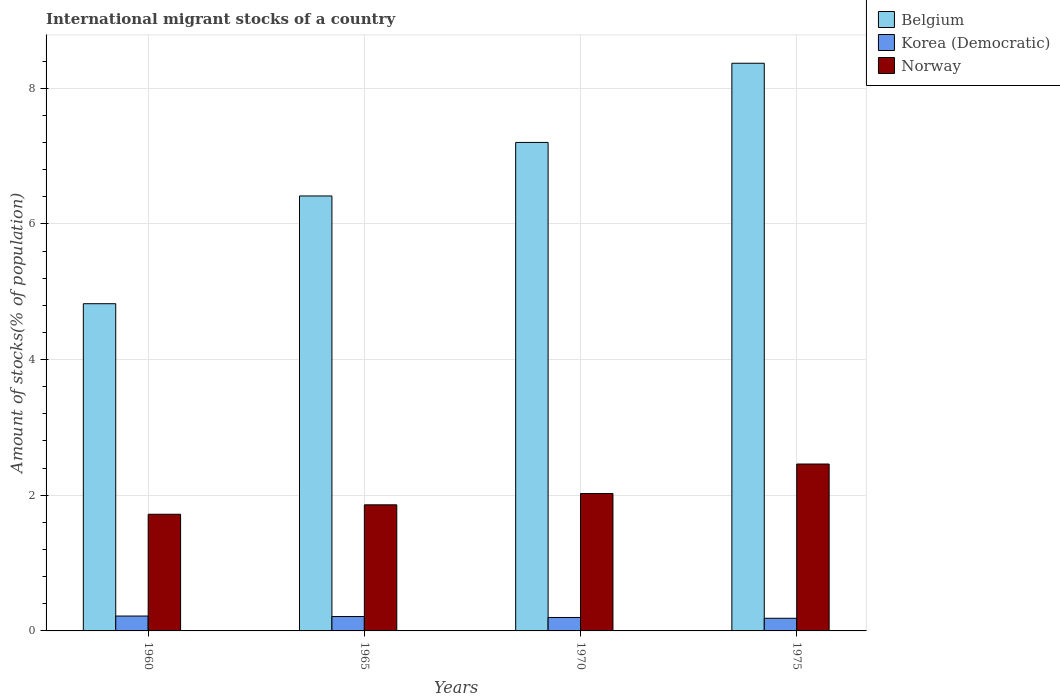How many different coloured bars are there?
Offer a very short reply. 3. Are the number of bars on each tick of the X-axis equal?
Your response must be concise. Yes. How many bars are there on the 1st tick from the left?
Make the answer very short. 3. What is the label of the 2nd group of bars from the left?
Provide a succinct answer. 1965. In how many cases, is the number of bars for a given year not equal to the number of legend labels?
Provide a short and direct response. 0. What is the amount of stocks in in Norway in 1965?
Provide a short and direct response. 1.86. Across all years, what is the maximum amount of stocks in in Korea (Democratic)?
Provide a succinct answer. 0.22. Across all years, what is the minimum amount of stocks in in Norway?
Provide a short and direct response. 1.72. In which year was the amount of stocks in in Belgium maximum?
Give a very brief answer. 1975. What is the total amount of stocks in in Belgium in the graph?
Your answer should be compact. 26.81. What is the difference between the amount of stocks in in Korea (Democratic) in 1960 and that in 1965?
Your answer should be compact. 0.01. What is the difference between the amount of stocks in in Belgium in 1970 and the amount of stocks in in Korea (Democratic) in 1960?
Ensure brevity in your answer.  6.98. What is the average amount of stocks in in Korea (Democratic) per year?
Ensure brevity in your answer.  0.2. In the year 1960, what is the difference between the amount of stocks in in Norway and amount of stocks in in Korea (Democratic)?
Make the answer very short. 1.5. In how many years, is the amount of stocks in in Korea (Democratic) greater than 6.8 %?
Keep it short and to the point. 0. What is the ratio of the amount of stocks in in Norway in 1960 to that in 1970?
Ensure brevity in your answer.  0.85. What is the difference between the highest and the second highest amount of stocks in in Korea (Democratic)?
Provide a succinct answer. 0.01. What is the difference between the highest and the lowest amount of stocks in in Belgium?
Make the answer very short. 3.54. What does the 1st bar from the left in 1960 represents?
Provide a succinct answer. Belgium. What does the 3rd bar from the right in 1965 represents?
Your response must be concise. Belgium. How many bars are there?
Provide a short and direct response. 12. What is the difference between two consecutive major ticks on the Y-axis?
Your response must be concise. 2. What is the title of the graph?
Your answer should be very brief. International migrant stocks of a country. What is the label or title of the X-axis?
Provide a succinct answer. Years. What is the label or title of the Y-axis?
Your answer should be compact. Amount of stocks(% of population). What is the Amount of stocks(% of population) of Belgium in 1960?
Keep it short and to the point. 4.82. What is the Amount of stocks(% of population) of Korea (Democratic) in 1960?
Keep it short and to the point. 0.22. What is the Amount of stocks(% of population) of Norway in 1960?
Give a very brief answer. 1.72. What is the Amount of stocks(% of population) in Belgium in 1965?
Your response must be concise. 6.41. What is the Amount of stocks(% of population) in Korea (Democratic) in 1965?
Make the answer very short. 0.21. What is the Amount of stocks(% of population) in Norway in 1965?
Ensure brevity in your answer.  1.86. What is the Amount of stocks(% of population) of Belgium in 1970?
Your response must be concise. 7.2. What is the Amount of stocks(% of population) of Korea (Democratic) in 1970?
Offer a very short reply. 0.2. What is the Amount of stocks(% of population) of Norway in 1970?
Make the answer very short. 2.03. What is the Amount of stocks(% of population) of Belgium in 1975?
Offer a terse response. 8.37. What is the Amount of stocks(% of population) of Korea (Democratic) in 1975?
Provide a succinct answer. 0.19. What is the Amount of stocks(% of population) in Norway in 1975?
Provide a succinct answer. 2.46. Across all years, what is the maximum Amount of stocks(% of population) of Belgium?
Offer a very short reply. 8.37. Across all years, what is the maximum Amount of stocks(% of population) of Korea (Democratic)?
Make the answer very short. 0.22. Across all years, what is the maximum Amount of stocks(% of population) in Norway?
Ensure brevity in your answer.  2.46. Across all years, what is the minimum Amount of stocks(% of population) in Belgium?
Your answer should be compact. 4.82. Across all years, what is the minimum Amount of stocks(% of population) in Korea (Democratic)?
Ensure brevity in your answer.  0.19. Across all years, what is the minimum Amount of stocks(% of population) in Norway?
Provide a short and direct response. 1.72. What is the total Amount of stocks(% of population) in Belgium in the graph?
Provide a short and direct response. 26.81. What is the total Amount of stocks(% of population) of Korea (Democratic) in the graph?
Provide a short and direct response. 0.82. What is the total Amount of stocks(% of population) of Norway in the graph?
Your answer should be compact. 8.06. What is the difference between the Amount of stocks(% of population) in Belgium in 1960 and that in 1965?
Offer a very short reply. -1.59. What is the difference between the Amount of stocks(% of population) of Korea (Democratic) in 1960 and that in 1965?
Your answer should be compact. 0.01. What is the difference between the Amount of stocks(% of population) in Norway in 1960 and that in 1965?
Make the answer very short. -0.14. What is the difference between the Amount of stocks(% of population) of Belgium in 1960 and that in 1970?
Your answer should be very brief. -2.38. What is the difference between the Amount of stocks(% of population) of Korea (Democratic) in 1960 and that in 1970?
Your response must be concise. 0.02. What is the difference between the Amount of stocks(% of population) in Norway in 1960 and that in 1970?
Your answer should be compact. -0.31. What is the difference between the Amount of stocks(% of population) in Belgium in 1960 and that in 1975?
Your response must be concise. -3.54. What is the difference between the Amount of stocks(% of population) in Korea (Democratic) in 1960 and that in 1975?
Your answer should be very brief. 0.03. What is the difference between the Amount of stocks(% of population) in Norway in 1960 and that in 1975?
Make the answer very short. -0.74. What is the difference between the Amount of stocks(% of population) in Belgium in 1965 and that in 1970?
Your answer should be very brief. -0.79. What is the difference between the Amount of stocks(% of population) in Korea (Democratic) in 1965 and that in 1970?
Your answer should be very brief. 0.01. What is the difference between the Amount of stocks(% of population) in Norway in 1965 and that in 1970?
Make the answer very short. -0.17. What is the difference between the Amount of stocks(% of population) in Belgium in 1965 and that in 1975?
Offer a very short reply. -1.96. What is the difference between the Amount of stocks(% of population) of Korea (Democratic) in 1965 and that in 1975?
Your answer should be compact. 0.03. What is the difference between the Amount of stocks(% of population) in Norway in 1965 and that in 1975?
Offer a terse response. -0.6. What is the difference between the Amount of stocks(% of population) of Belgium in 1970 and that in 1975?
Offer a terse response. -1.17. What is the difference between the Amount of stocks(% of population) of Korea (Democratic) in 1970 and that in 1975?
Offer a very short reply. 0.01. What is the difference between the Amount of stocks(% of population) of Norway in 1970 and that in 1975?
Ensure brevity in your answer.  -0.43. What is the difference between the Amount of stocks(% of population) of Belgium in 1960 and the Amount of stocks(% of population) of Korea (Democratic) in 1965?
Offer a very short reply. 4.61. What is the difference between the Amount of stocks(% of population) in Belgium in 1960 and the Amount of stocks(% of population) in Norway in 1965?
Give a very brief answer. 2.96. What is the difference between the Amount of stocks(% of population) in Korea (Democratic) in 1960 and the Amount of stocks(% of population) in Norway in 1965?
Ensure brevity in your answer.  -1.64. What is the difference between the Amount of stocks(% of population) of Belgium in 1960 and the Amount of stocks(% of population) of Korea (Democratic) in 1970?
Your answer should be very brief. 4.63. What is the difference between the Amount of stocks(% of population) in Belgium in 1960 and the Amount of stocks(% of population) in Norway in 1970?
Give a very brief answer. 2.8. What is the difference between the Amount of stocks(% of population) of Korea (Democratic) in 1960 and the Amount of stocks(% of population) of Norway in 1970?
Offer a very short reply. -1.81. What is the difference between the Amount of stocks(% of population) in Belgium in 1960 and the Amount of stocks(% of population) in Korea (Democratic) in 1975?
Your response must be concise. 4.64. What is the difference between the Amount of stocks(% of population) of Belgium in 1960 and the Amount of stocks(% of population) of Norway in 1975?
Ensure brevity in your answer.  2.36. What is the difference between the Amount of stocks(% of population) in Korea (Democratic) in 1960 and the Amount of stocks(% of population) in Norway in 1975?
Make the answer very short. -2.24. What is the difference between the Amount of stocks(% of population) of Belgium in 1965 and the Amount of stocks(% of population) of Korea (Democratic) in 1970?
Make the answer very short. 6.21. What is the difference between the Amount of stocks(% of population) in Belgium in 1965 and the Amount of stocks(% of population) in Norway in 1970?
Your answer should be compact. 4.39. What is the difference between the Amount of stocks(% of population) in Korea (Democratic) in 1965 and the Amount of stocks(% of population) in Norway in 1970?
Your answer should be compact. -1.81. What is the difference between the Amount of stocks(% of population) of Belgium in 1965 and the Amount of stocks(% of population) of Korea (Democratic) in 1975?
Make the answer very short. 6.23. What is the difference between the Amount of stocks(% of population) of Belgium in 1965 and the Amount of stocks(% of population) of Norway in 1975?
Make the answer very short. 3.95. What is the difference between the Amount of stocks(% of population) of Korea (Democratic) in 1965 and the Amount of stocks(% of population) of Norway in 1975?
Make the answer very short. -2.25. What is the difference between the Amount of stocks(% of population) of Belgium in 1970 and the Amount of stocks(% of population) of Korea (Democratic) in 1975?
Ensure brevity in your answer.  7.02. What is the difference between the Amount of stocks(% of population) of Belgium in 1970 and the Amount of stocks(% of population) of Norway in 1975?
Provide a short and direct response. 4.74. What is the difference between the Amount of stocks(% of population) of Korea (Democratic) in 1970 and the Amount of stocks(% of population) of Norway in 1975?
Provide a succinct answer. -2.26. What is the average Amount of stocks(% of population) of Belgium per year?
Your response must be concise. 6.7. What is the average Amount of stocks(% of population) in Korea (Democratic) per year?
Give a very brief answer. 0.2. What is the average Amount of stocks(% of population) in Norway per year?
Keep it short and to the point. 2.02. In the year 1960, what is the difference between the Amount of stocks(% of population) of Belgium and Amount of stocks(% of population) of Korea (Democratic)?
Keep it short and to the point. 4.6. In the year 1960, what is the difference between the Amount of stocks(% of population) of Belgium and Amount of stocks(% of population) of Norway?
Offer a terse response. 3.1. In the year 1960, what is the difference between the Amount of stocks(% of population) in Korea (Democratic) and Amount of stocks(% of population) in Norway?
Give a very brief answer. -1.5. In the year 1965, what is the difference between the Amount of stocks(% of population) of Belgium and Amount of stocks(% of population) of Korea (Democratic)?
Provide a short and direct response. 6.2. In the year 1965, what is the difference between the Amount of stocks(% of population) of Belgium and Amount of stocks(% of population) of Norway?
Provide a short and direct response. 4.55. In the year 1965, what is the difference between the Amount of stocks(% of population) of Korea (Democratic) and Amount of stocks(% of population) of Norway?
Your answer should be very brief. -1.65. In the year 1970, what is the difference between the Amount of stocks(% of population) in Belgium and Amount of stocks(% of population) in Korea (Democratic)?
Give a very brief answer. 7. In the year 1970, what is the difference between the Amount of stocks(% of population) of Belgium and Amount of stocks(% of population) of Norway?
Keep it short and to the point. 5.18. In the year 1970, what is the difference between the Amount of stocks(% of population) in Korea (Democratic) and Amount of stocks(% of population) in Norway?
Your response must be concise. -1.83. In the year 1975, what is the difference between the Amount of stocks(% of population) of Belgium and Amount of stocks(% of population) of Korea (Democratic)?
Provide a succinct answer. 8.18. In the year 1975, what is the difference between the Amount of stocks(% of population) of Belgium and Amount of stocks(% of population) of Norway?
Your answer should be compact. 5.91. In the year 1975, what is the difference between the Amount of stocks(% of population) of Korea (Democratic) and Amount of stocks(% of population) of Norway?
Your answer should be compact. -2.27. What is the ratio of the Amount of stocks(% of population) in Belgium in 1960 to that in 1965?
Provide a short and direct response. 0.75. What is the ratio of the Amount of stocks(% of population) in Korea (Democratic) in 1960 to that in 1965?
Keep it short and to the point. 1.04. What is the ratio of the Amount of stocks(% of population) of Norway in 1960 to that in 1965?
Ensure brevity in your answer.  0.93. What is the ratio of the Amount of stocks(% of population) of Belgium in 1960 to that in 1970?
Offer a terse response. 0.67. What is the ratio of the Amount of stocks(% of population) of Korea (Democratic) in 1960 to that in 1970?
Your answer should be very brief. 1.11. What is the ratio of the Amount of stocks(% of population) in Norway in 1960 to that in 1970?
Provide a short and direct response. 0.85. What is the ratio of the Amount of stocks(% of population) of Belgium in 1960 to that in 1975?
Your answer should be compact. 0.58. What is the ratio of the Amount of stocks(% of population) in Korea (Democratic) in 1960 to that in 1975?
Make the answer very short. 1.18. What is the ratio of the Amount of stocks(% of population) of Norway in 1960 to that in 1975?
Your answer should be compact. 0.7. What is the ratio of the Amount of stocks(% of population) of Belgium in 1965 to that in 1970?
Your answer should be compact. 0.89. What is the ratio of the Amount of stocks(% of population) of Korea (Democratic) in 1965 to that in 1970?
Provide a short and direct response. 1.07. What is the ratio of the Amount of stocks(% of population) in Norway in 1965 to that in 1970?
Provide a succinct answer. 0.92. What is the ratio of the Amount of stocks(% of population) of Belgium in 1965 to that in 1975?
Provide a succinct answer. 0.77. What is the ratio of the Amount of stocks(% of population) of Korea (Democratic) in 1965 to that in 1975?
Your response must be concise. 1.14. What is the ratio of the Amount of stocks(% of population) of Norway in 1965 to that in 1975?
Keep it short and to the point. 0.76. What is the ratio of the Amount of stocks(% of population) of Belgium in 1970 to that in 1975?
Your response must be concise. 0.86. What is the ratio of the Amount of stocks(% of population) of Korea (Democratic) in 1970 to that in 1975?
Offer a very short reply. 1.06. What is the ratio of the Amount of stocks(% of population) of Norway in 1970 to that in 1975?
Provide a short and direct response. 0.82. What is the difference between the highest and the second highest Amount of stocks(% of population) of Belgium?
Offer a terse response. 1.17. What is the difference between the highest and the second highest Amount of stocks(% of population) in Korea (Democratic)?
Offer a very short reply. 0.01. What is the difference between the highest and the second highest Amount of stocks(% of population) in Norway?
Your answer should be compact. 0.43. What is the difference between the highest and the lowest Amount of stocks(% of population) of Belgium?
Keep it short and to the point. 3.54. What is the difference between the highest and the lowest Amount of stocks(% of population) in Korea (Democratic)?
Keep it short and to the point. 0.03. What is the difference between the highest and the lowest Amount of stocks(% of population) of Norway?
Keep it short and to the point. 0.74. 